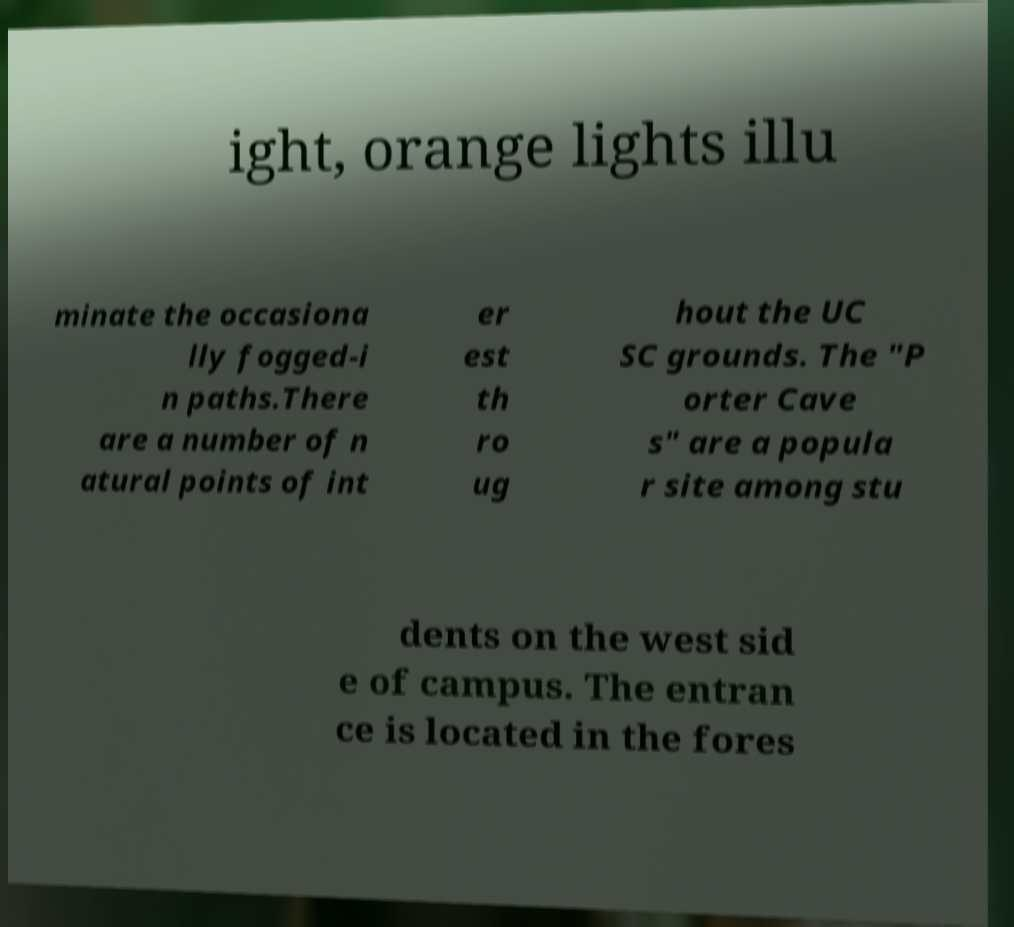Could you assist in decoding the text presented in this image and type it out clearly? ight, orange lights illu minate the occasiona lly fogged-i n paths.There are a number of n atural points of int er est th ro ug hout the UC SC grounds. The "P orter Cave s" are a popula r site among stu dents on the west sid e of campus. The entran ce is located in the fores 